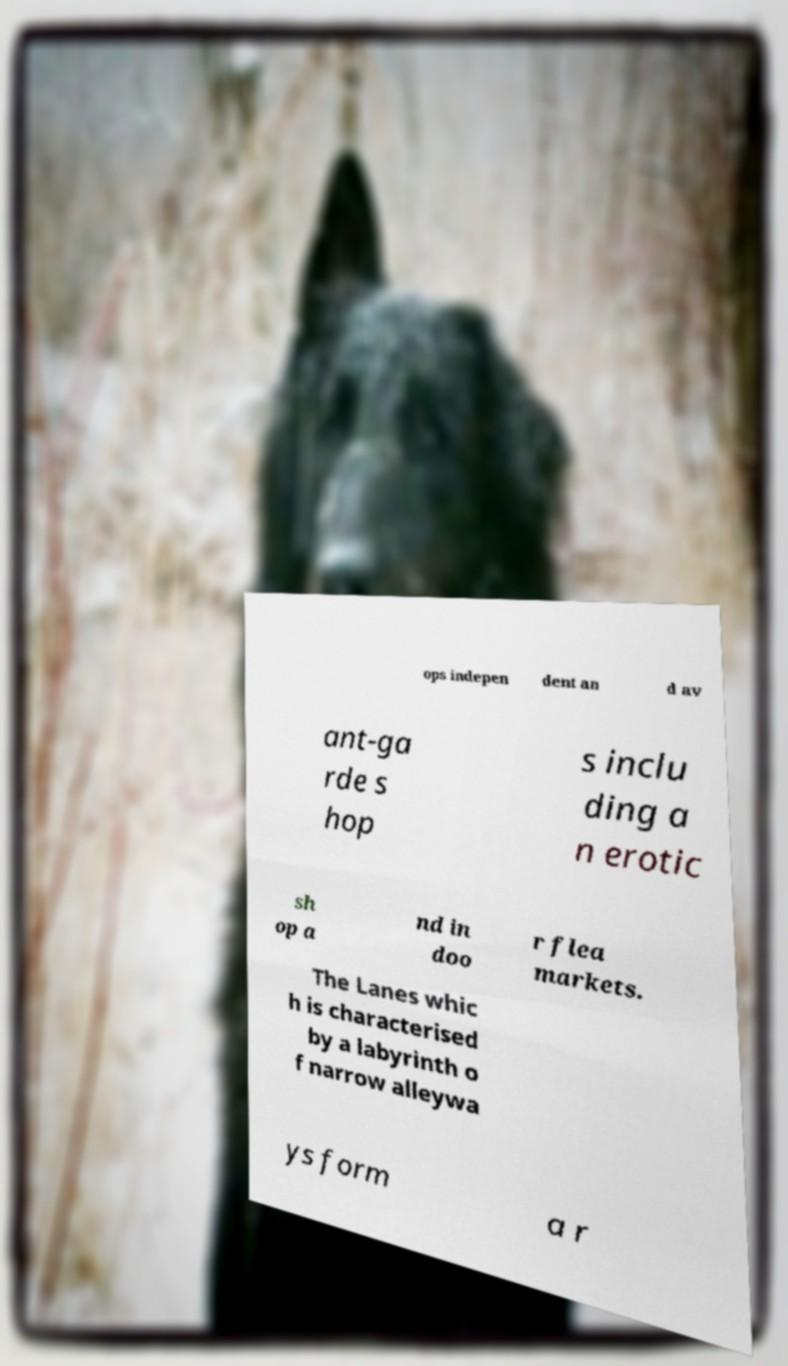Can you read and provide the text displayed in the image?This photo seems to have some interesting text. Can you extract and type it out for me? ops indepen dent an d av ant-ga rde s hop s inclu ding a n erotic sh op a nd in doo r flea markets. The Lanes whic h is characterised by a labyrinth o f narrow alleywa ys form a r 